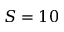<formula> <loc_0><loc_0><loc_500><loc_500>S = 1 0</formula> 